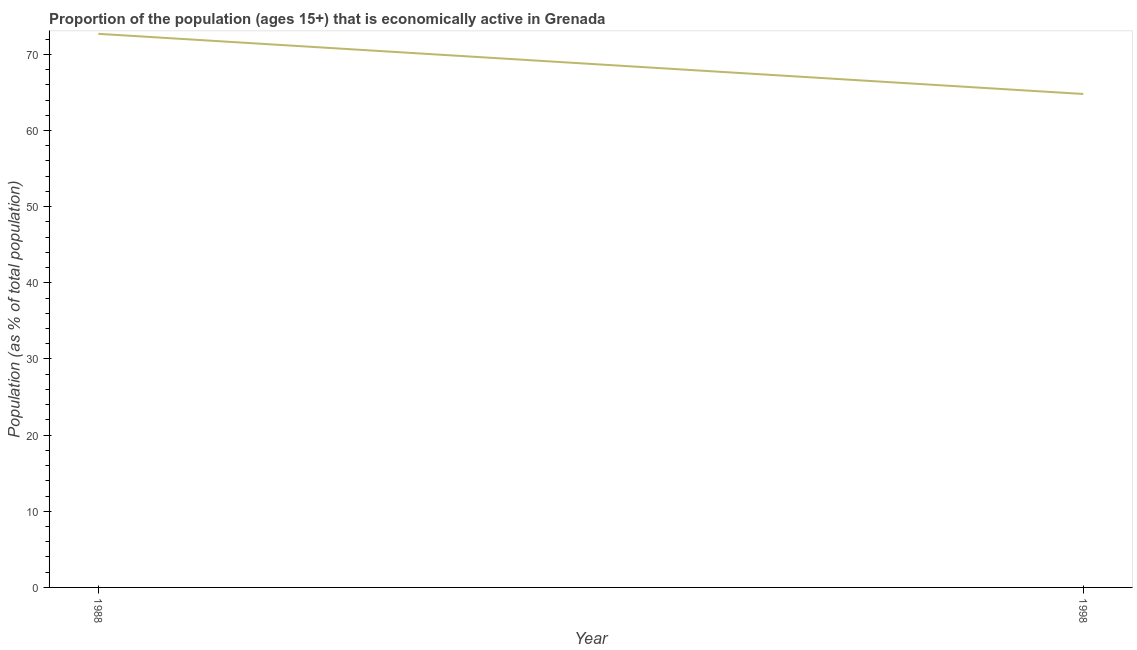What is the percentage of economically active population in 1998?
Offer a terse response. 64.8. Across all years, what is the maximum percentage of economically active population?
Offer a very short reply. 72.7. Across all years, what is the minimum percentage of economically active population?
Make the answer very short. 64.8. In which year was the percentage of economically active population maximum?
Make the answer very short. 1988. What is the sum of the percentage of economically active population?
Offer a terse response. 137.5. What is the difference between the percentage of economically active population in 1988 and 1998?
Offer a terse response. 7.9. What is the average percentage of economically active population per year?
Keep it short and to the point. 68.75. What is the median percentage of economically active population?
Offer a terse response. 68.75. In how many years, is the percentage of economically active population greater than 22 %?
Your answer should be very brief. 2. What is the ratio of the percentage of economically active population in 1988 to that in 1998?
Your answer should be compact. 1.12. In how many years, is the percentage of economically active population greater than the average percentage of economically active population taken over all years?
Make the answer very short. 1. Does the percentage of economically active population monotonically increase over the years?
Provide a short and direct response. No. How many lines are there?
Keep it short and to the point. 1. How many years are there in the graph?
Offer a terse response. 2. What is the difference between two consecutive major ticks on the Y-axis?
Your answer should be very brief. 10. Are the values on the major ticks of Y-axis written in scientific E-notation?
Your answer should be compact. No. Does the graph contain grids?
Ensure brevity in your answer.  No. What is the title of the graph?
Your answer should be very brief. Proportion of the population (ages 15+) that is economically active in Grenada. What is the label or title of the Y-axis?
Offer a very short reply. Population (as % of total population). What is the Population (as % of total population) of 1988?
Make the answer very short. 72.7. What is the Population (as % of total population) of 1998?
Provide a succinct answer. 64.8. What is the difference between the Population (as % of total population) in 1988 and 1998?
Give a very brief answer. 7.9. What is the ratio of the Population (as % of total population) in 1988 to that in 1998?
Offer a very short reply. 1.12. 